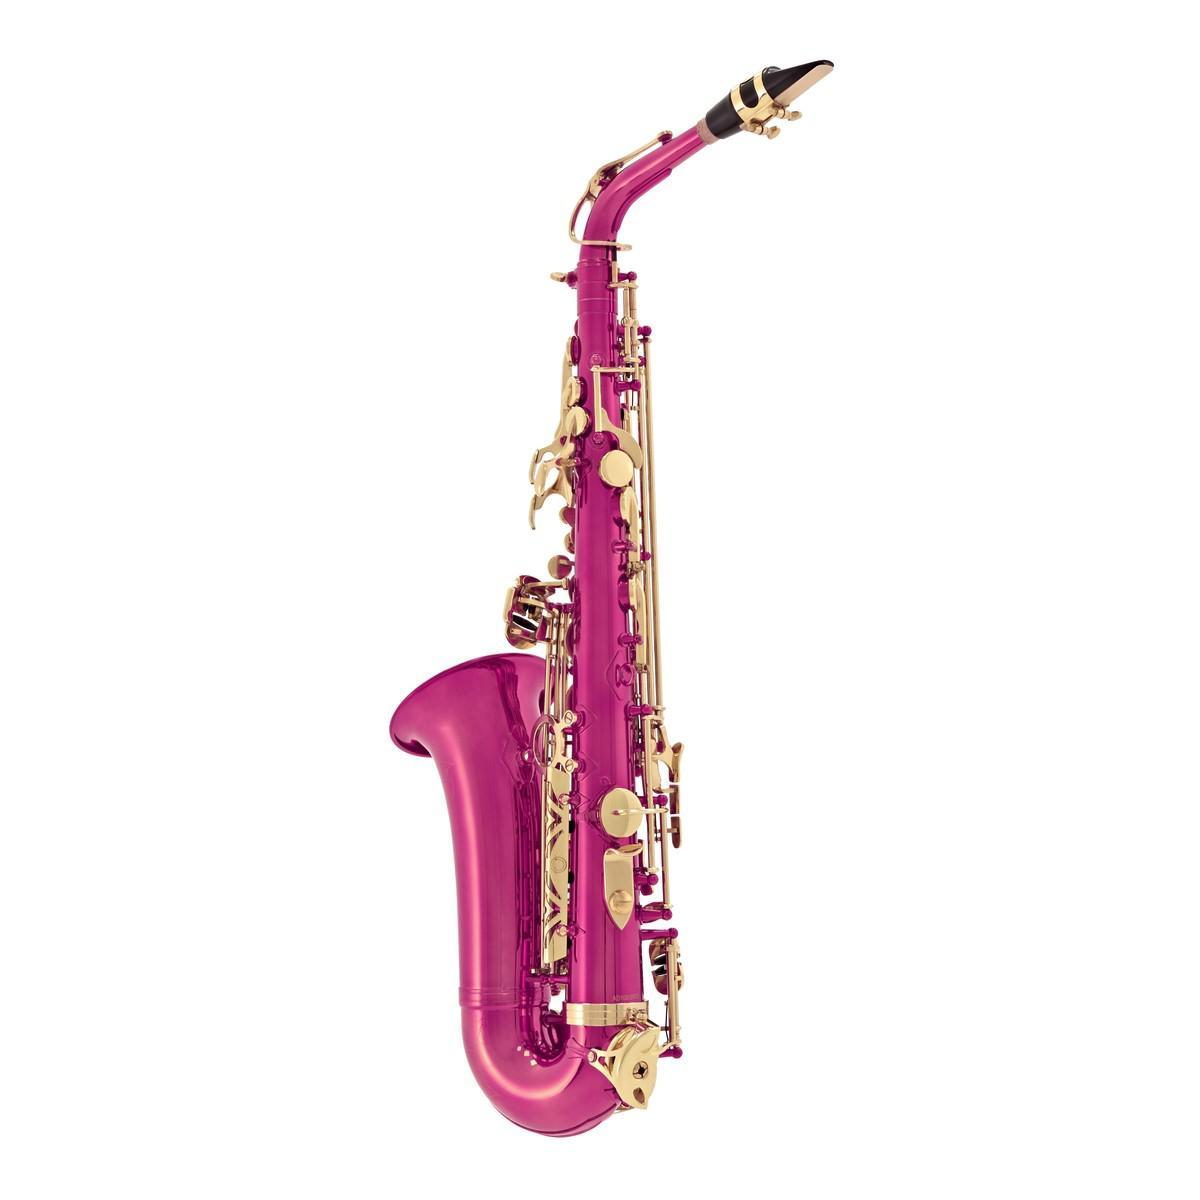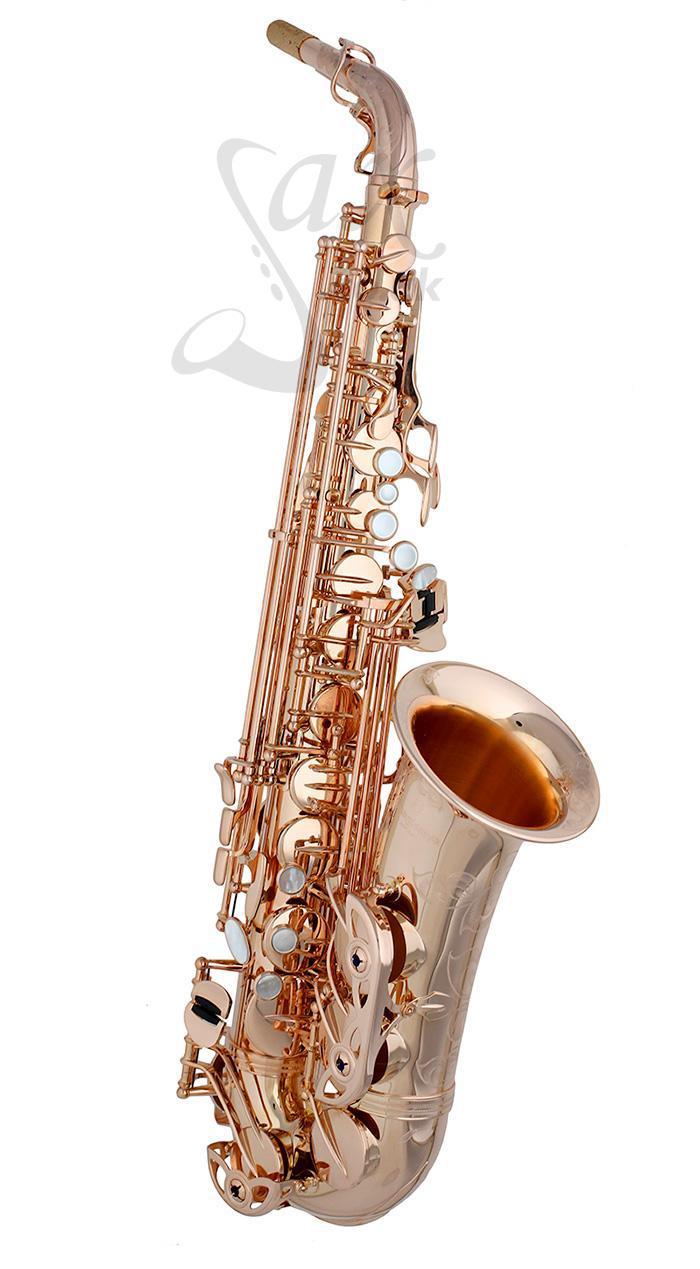The first image is the image on the left, the second image is the image on the right. Assess this claim about the two images: "One saxophone has a traditional metallic colored body, and the other has a body colored some shade of pink.". Correct or not? Answer yes or no. Yes. 